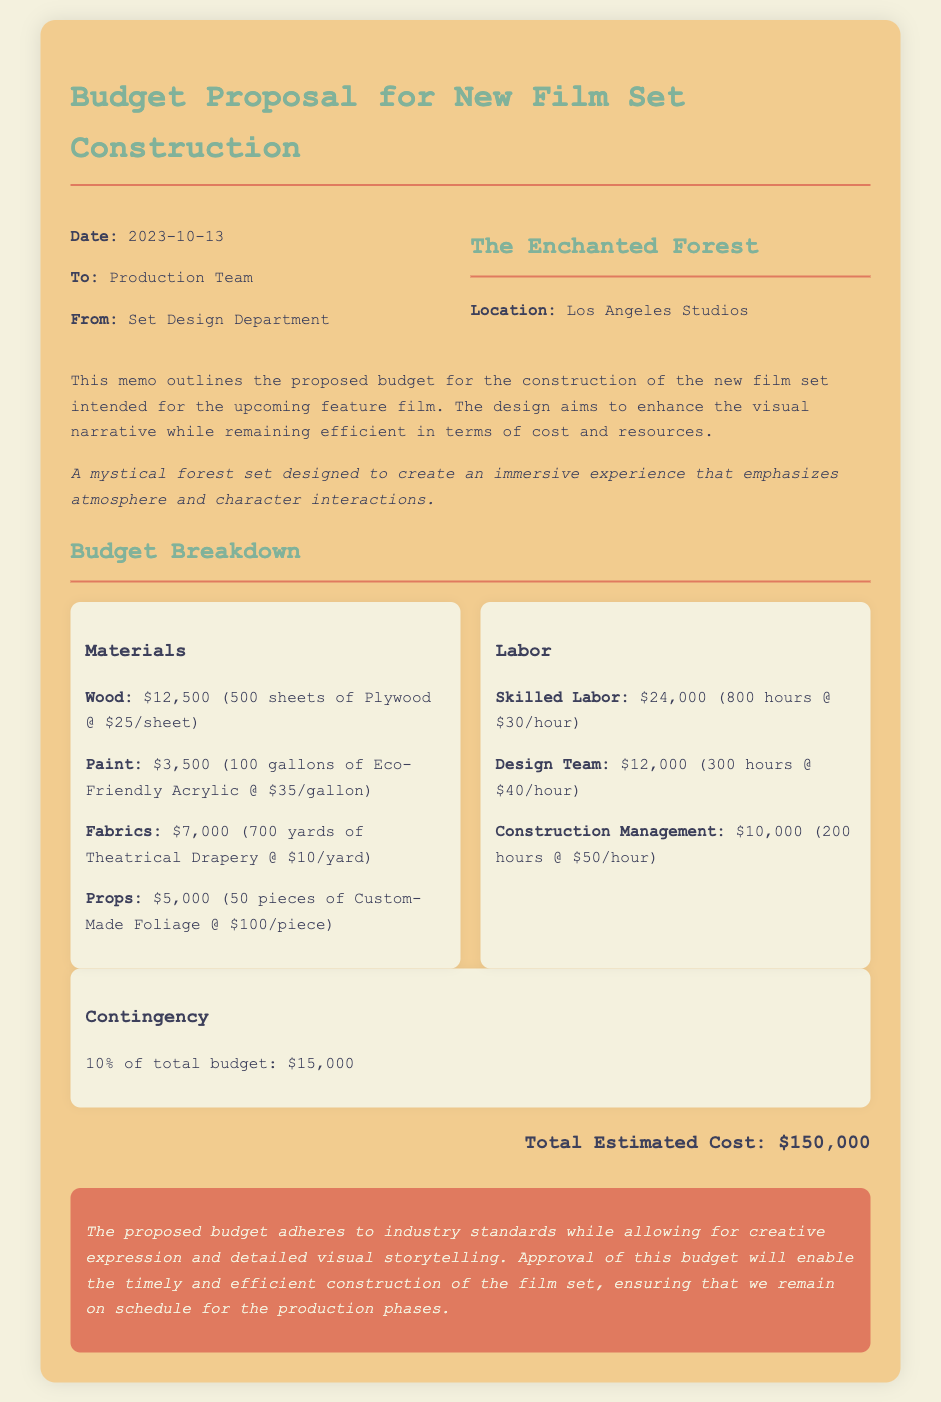What is the date of the memo? The memo was dated October 13, 2023.
Answer: October 13, 2023 Who is the memo addressed to? The memo is addressed to the production team.
Answer: Production Team What is the total estimated cost of the project? The total estimated cost is explicitly stated at the bottom of the memo.
Answer: $150,000 How much is allocated for materials? The materials cost is listed in the budget breakdown section of the memo.
Answer: $28,000 What percentage of the total budget is the contingency? The contingency is stated as 10% of the total budget in the document.
Answer: 10% What type of set is being proposed? The proposal describes the type of set in its introduction.
Answer: Enchanted Forest How many hours of skilled labor are included in the budget? The hours of skilled labor are mentioned in the labor cost breakdown.
Answer: 800 hours What is the cost per gallon of paint? The cost of paint is specified alongside its quantity in the budget breakdown.
Answer: $35/gallon What is the primary focus of the set design? The focus of the set design is reiterated in the conclusion of the memo.
Answer: Visual storytelling 